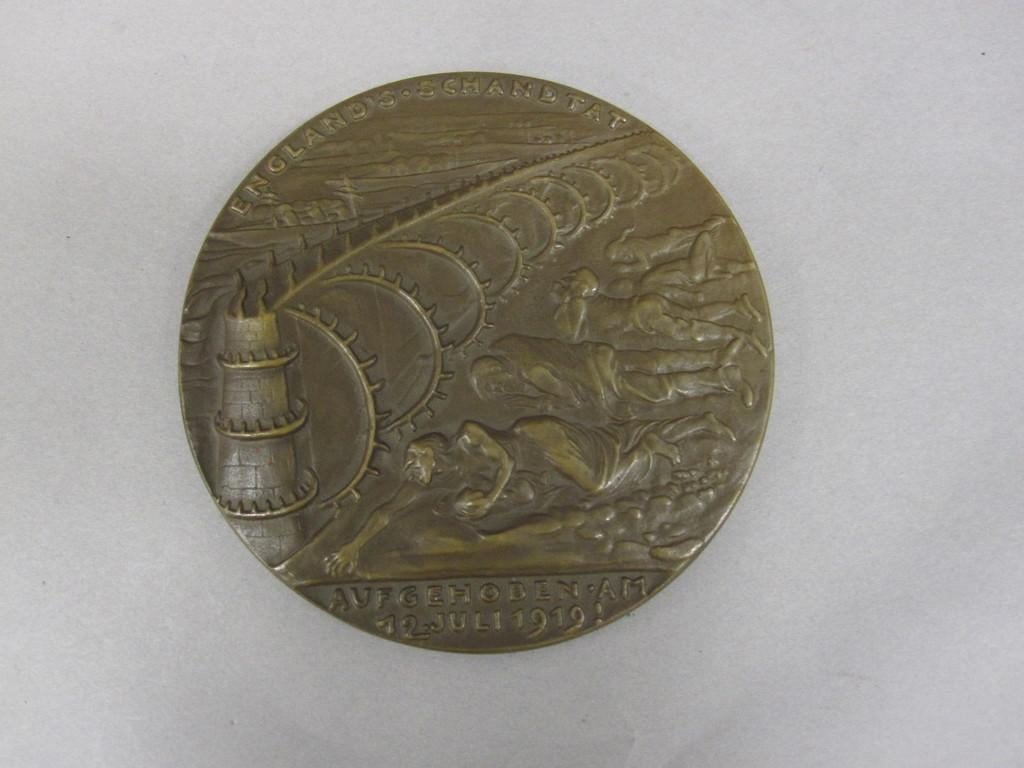<image>
Describe the image concisely. an old english metal coin minted in 1919 